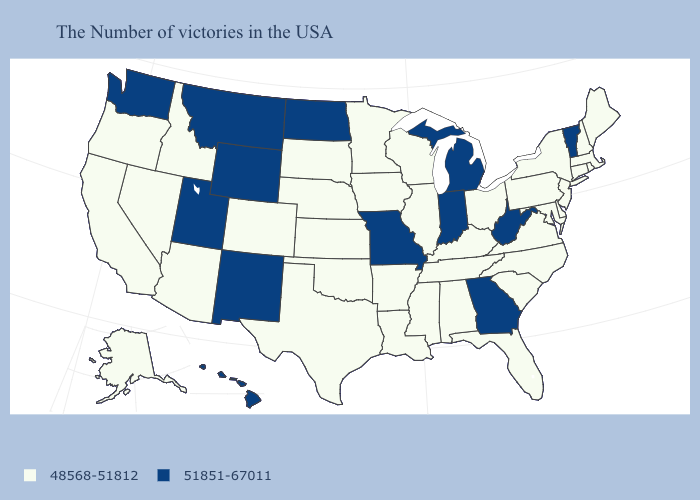Does Connecticut have the lowest value in the Northeast?
Keep it brief. Yes. Among the states that border Vermont , which have the highest value?
Quick response, please. Massachusetts, New Hampshire, New York. Among the states that border Georgia , which have the highest value?
Short answer required. North Carolina, South Carolina, Florida, Alabama, Tennessee. Does Missouri have a higher value than Delaware?
Answer briefly. Yes. Does the first symbol in the legend represent the smallest category?
Write a very short answer. Yes. Name the states that have a value in the range 51851-67011?
Short answer required. Vermont, West Virginia, Georgia, Michigan, Indiana, Missouri, North Dakota, Wyoming, New Mexico, Utah, Montana, Washington, Hawaii. Does Virginia have the highest value in the USA?
Quick response, please. No. What is the value of Alabama?
Give a very brief answer. 48568-51812. What is the value of Oregon?
Short answer required. 48568-51812. What is the value of California?
Give a very brief answer. 48568-51812. What is the lowest value in the West?
Answer briefly. 48568-51812. Which states have the lowest value in the USA?
Be succinct. Maine, Massachusetts, Rhode Island, New Hampshire, Connecticut, New York, New Jersey, Delaware, Maryland, Pennsylvania, Virginia, North Carolina, South Carolina, Ohio, Florida, Kentucky, Alabama, Tennessee, Wisconsin, Illinois, Mississippi, Louisiana, Arkansas, Minnesota, Iowa, Kansas, Nebraska, Oklahoma, Texas, South Dakota, Colorado, Arizona, Idaho, Nevada, California, Oregon, Alaska. Is the legend a continuous bar?
Write a very short answer. No. Among the states that border Kansas , does Missouri have the lowest value?
Concise answer only. No. Name the states that have a value in the range 51851-67011?
Give a very brief answer. Vermont, West Virginia, Georgia, Michigan, Indiana, Missouri, North Dakota, Wyoming, New Mexico, Utah, Montana, Washington, Hawaii. 